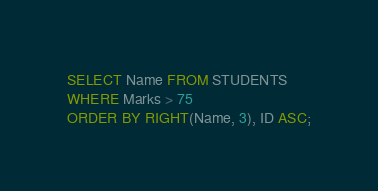Convert code to text. <code><loc_0><loc_0><loc_500><loc_500><_SQL_>SELECT Name FROM STUDENTS
WHERE Marks > 75
ORDER BY RIGHT(Name, 3), ID ASC;</code> 